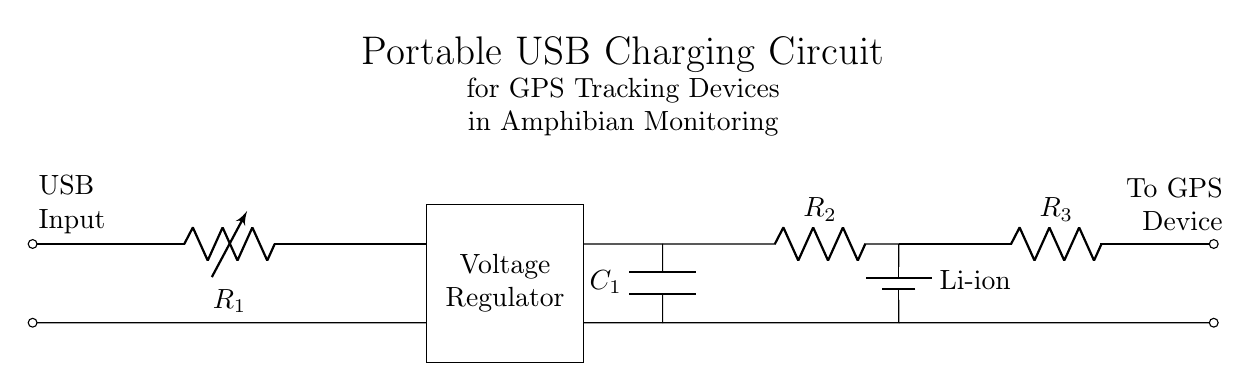What is the input source for this circuit? The input source is USB, identified by the label "USB Input" in the circuit diagram. This indicates that the circuit is powered by a USB connection.
Answer: USB What type of battery is used in this circuit? The circuit uses a lithium-ion battery as indicated by the label "Li-ion" near the battery symbol in the diagram. This specifies the type of rechargeable battery employed.
Answer: Lithium-ion What is the function of the voltage regulator in this circuit? The voltage regulator ensures that the output voltage is consistent and appropriate for the GPS device, regardless of fluctuations in the input voltage from the USB source. This is essential for proper device operation.
Answer: Consistent voltage output How many resistors are present in the circuit? There are three resistors labeled as R1, R2, and R3 in the circuit diagram. Each resistor is positioned at different points within the circuit, serving various functions.
Answer: Three What is the role of the output capacitor in the circuit? The output capacitor, labeled C1, smooths out fluctuations in voltage after regulation, stabilizing the voltage delivered to the battery and GPS device. This helps in providing a cleaner power supply.
Answer: Smoothing voltage What is the output destination of the circuit? The output destination is the GPS device, as indicated by the label "To GPS Device". This specifies where the power generated in the circuit is intended to go.
Answer: GPS device Why is a charging circuit necessary for amphibian monitoring devices? A charging circuit is necessary as GPS tracking devices used for amphibian monitoring rely on rechargeable power sources to function continuously in the field. This extends operational time and ensures data collection is not interrupted.
Answer: Continuous power supply 